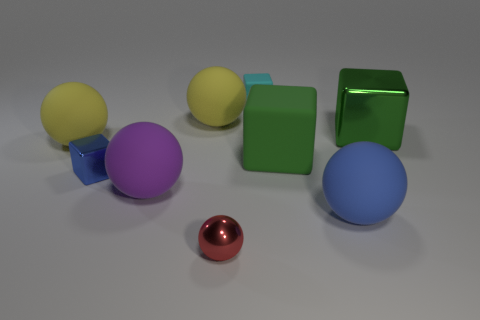Subtract all purple spheres. How many spheres are left? 4 Subtract all big purple matte spheres. How many spheres are left? 4 Subtract 1 blocks. How many blocks are left? 3 Add 1 large gray matte balls. How many objects exist? 10 Subtract all brown blocks. Subtract all gray spheres. How many blocks are left? 4 Subtract all balls. How many objects are left? 4 Add 7 red spheres. How many red spheres exist? 8 Subtract 0 cyan cylinders. How many objects are left? 9 Subtract all tiny spheres. Subtract all blue cylinders. How many objects are left? 8 Add 3 metal balls. How many metal balls are left? 4 